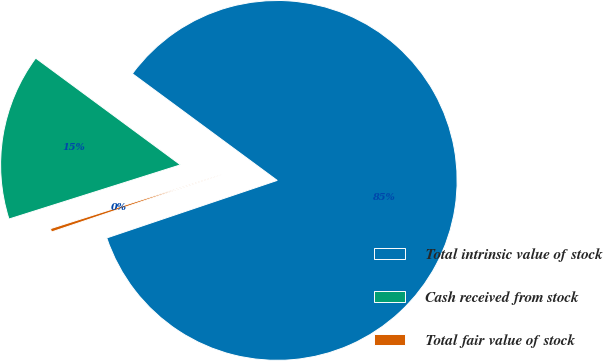Convert chart to OTSL. <chart><loc_0><loc_0><loc_500><loc_500><pie_chart><fcel>Total intrinsic value of stock<fcel>Cash received from stock<fcel>Total fair value of stock<nl><fcel>84.71%<fcel>14.98%<fcel>0.31%<nl></chart> 